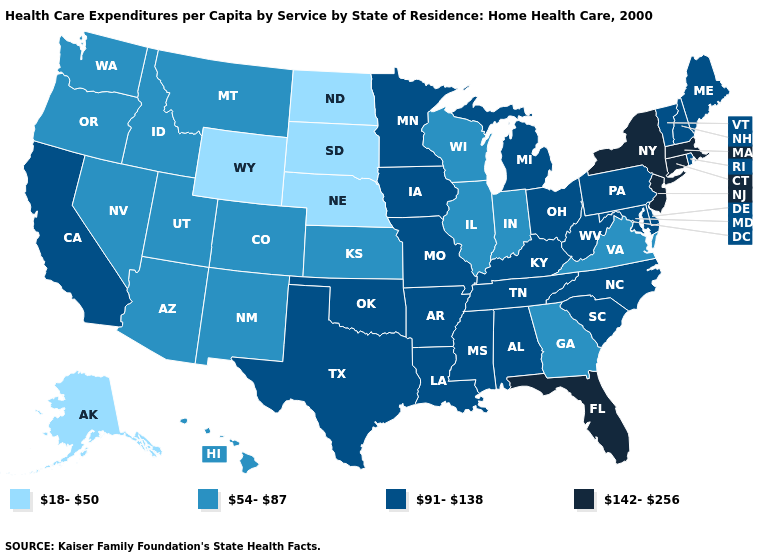What is the value of Illinois?
Quick response, please. 54-87. What is the value of Louisiana?
Answer briefly. 91-138. Name the states that have a value in the range 142-256?
Concise answer only. Connecticut, Florida, Massachusetts, New Jersey, New York. What is the lowest value in the USA?
Keep it brief. 18-50. Does Connecticut have the highest value in the Northeast?
Short answer required. Yes. Which states have the lowest value in the USA?
Keep it brief. Alaska, Nebraska, North Dakota, South Dakota, Wyoming. Which states have the lowest value in the MidWest?
Concise answer only. Nebraska, North Dakota, South Dakota. What is the value of New Hampshire?
Short answer required. 91-138. What is the value of New York?
Write a very short answer. 142-256. What is the value of Maine?
Answer briefly. 91-138. Name the states that have a value in the range 54-87?
Keep it brief. Arizona, Colorado, Georgia, Hawaii, Idaho, Illinois, Indiana, Kansas, Montana, Nevada, New Mexico, Oregon, Utah, Virginia, Washington, Wisconsin. Name the states that have a value in the range 54-87?
Write a very short answer. Arizona, Colorado, Georgia, Hawaii, Idaho, Illinois, Indiana, Kansas, Montana, Nevada, New Mexico, Oregon, Utah, Virginia, Washington, Wisconsin. What is the highest value in states that border Tennessee?
Quick response, please. 91-138. Does Minnesota have the lowest value in the MidWest?
Quick response, please. No. Name the states that have a value in the range 142-256?
Give a very brief answer. Connecticut, Florida, Massachusetts, New Jersey, New York. 